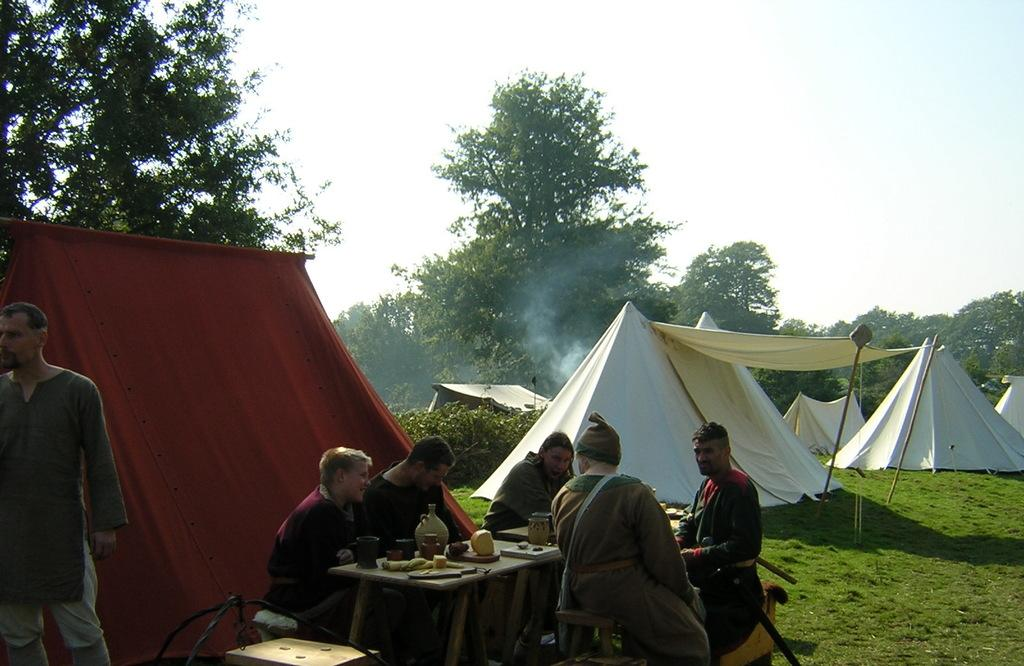How many people are in the image? There is a group of people in the image, but the exact number is not specified. What are the people doing in the image? The people are sitting on chairs in the image. What can be seen on the table in the image? There is a table with food in the image. What type of structures are present in the image? There are tents built in the image. What type of vegetation is visible in the image? There are trees in the image. What is the condition of the sky in the image? The sky is clear in the image. What type of knee is visible in the image? There is no specific knee visible in the image; it is a group of people sitting on chairs. What type of pancake is being served at the event in the image? There is no mention of pancakes or any food event in the image. 